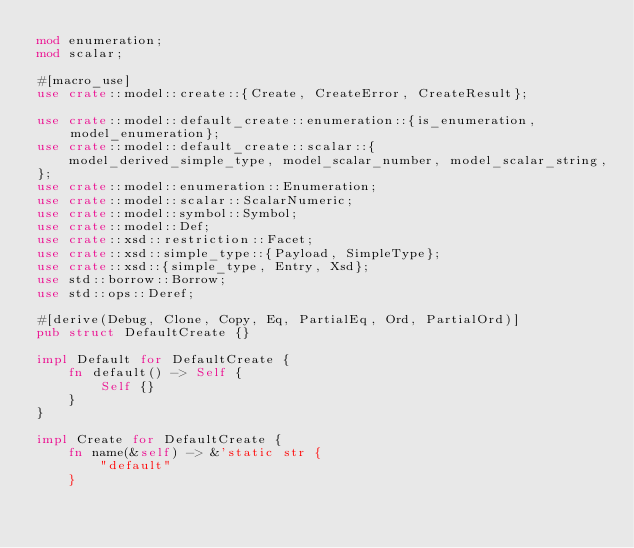Convert code to text. <code><loc_0><loc_0><loc_500><loc_500><_Rust_>mod enumeration;
mod scalar;

#[macro_use]
use crate::model::create::{Create, CreateError, CreateResult};

use crate::model::default_create::enumeration::{is_enumeration, model_enumeration};
use crate::model::default_create::scalar::{
    model_derived_simple_type, model_scalar_number, model_scalar_string,
};
use crate::model::enumeration::Enumeration;
use crate::model::scalar::ScalarNumeric;
use crate::model::symbol::Symbol;
use crate::model::Def;
use crate::xsd::restriction::Facet;
use crate::xsd::simple_type::{Payload, SimpleType};
use crate::xsd::{simple_type, Entry, Xsd};
use std::borrow::Borrow;
use std::ops::Deref;

#[derive(Debug, Clone, Copy, Eq, PartialEq, Ord, PartialOrd)]
pub struct DefaultCreate {}

impl Default for DefaultCreate {
    fn default() -> Self {
        Self {}
    }
}

impl Create for DefaultCreate {
    fn name(&self) -> &'static str {
        "default"
    }
</code> 